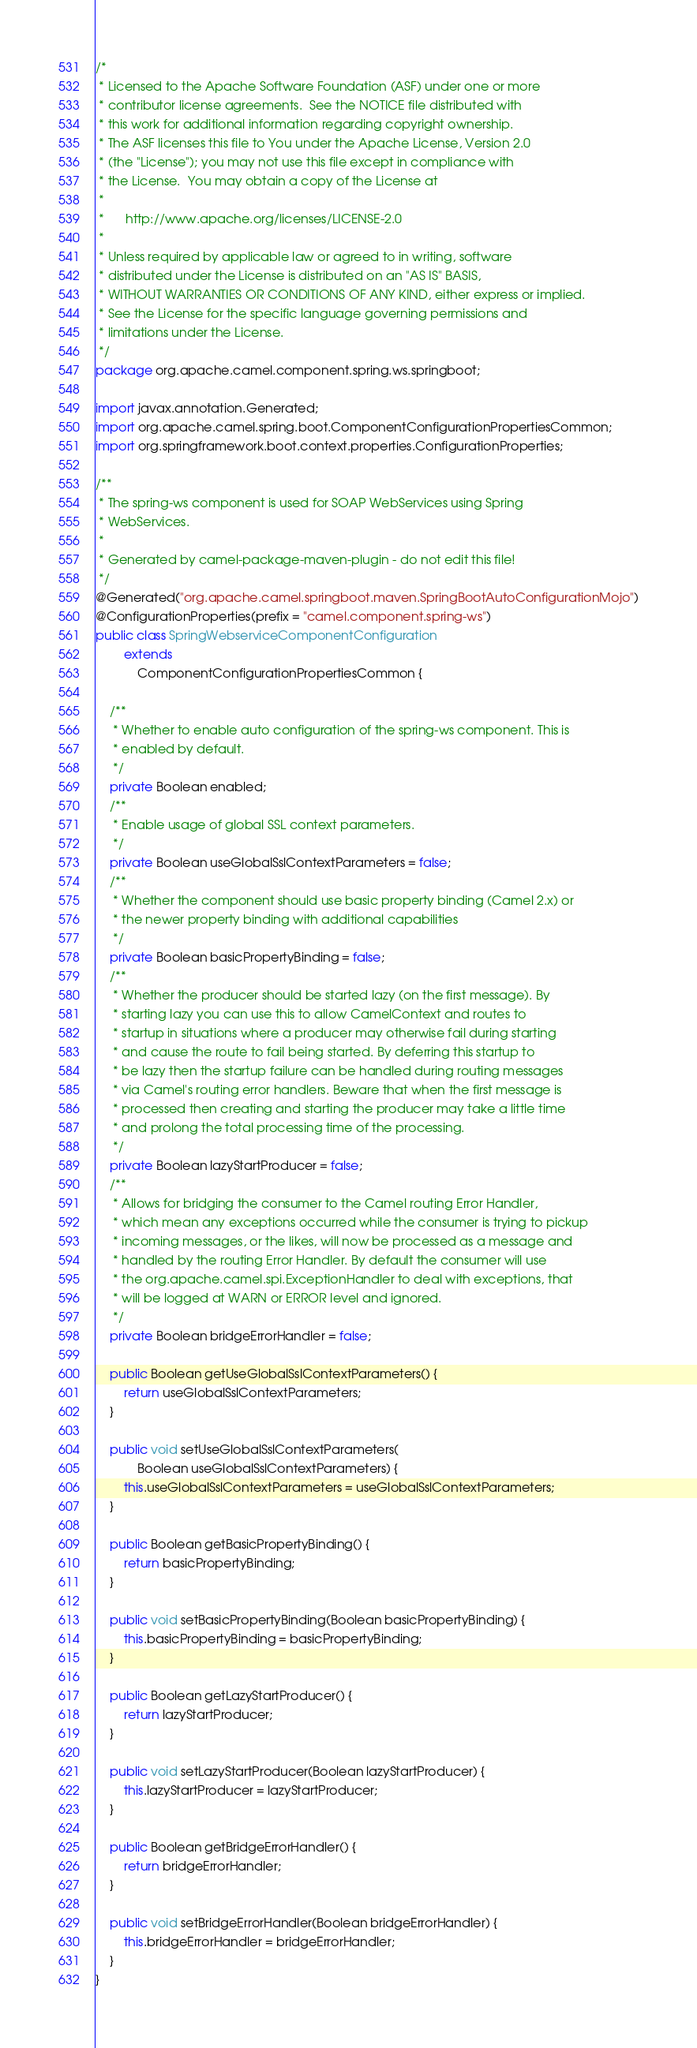Convert code to text. <code><loc_0><loc_0><loc_500><loc_500><_Java_>/*
 * Licensed to the Apache Software Foundation (ASF) under one or more
 * contributor license agreements.  See the NOTICE file distributed with
 * this work for additional information regarding copyright ownership.
 * The ASF licenses this file to You under the Apache License, Version 2.0
 * (the "License"); you may not use this file except in compliance with
 * the License.  You may obtain a copy of the License at
 *
 *      http://www.apache.org/licenses/LICENSE-2.0
 *
 * Unless required by applicable law or agreed to in writing, software
 * distributed under the License is distributed on an "AS IS" BASIS,
 * WITHOUT WARRANTIES OR CONDITIONS OF ANY KIND, either express or implied.
 * See the License for the specific language governing permissions and
 * limitations under the License.
 */
package org.apache.camel.component.spring.ws.springboot;

import javax.annotation.Generated;
import org.apache.camel.spring.boot.ComponentConfigurationPropertiesCommon;
import org.springframework.boot.context.properties.ConfigurationProperties;

/**
 * The spring-ws component is used for SOAP WebServices using Spring
 * WebServices.
 * 
 * Generated by camel-package-maven-plugin - do not edit this file!
 */
@Generated("org.apache.camel.springboot.maven.SpringBootAutoConfigurationMojo")
@ConfigurationProperties(prefix = "camel.component.spring-ws")
public class SpringWebserviceComponentConfiguration
        extends
            ComponentConfigurationPropertiesCommon {

    /**
     * Whether to enable auto configuration of the spring-ws component. This is
     * enabled by default.
     */
    private Boolean enabled;
    /**
     * Enable usage of global SSL context parameters.
     */
    private Boolean useGlobalSslContextParameters = false;
    /**
     * Whether the component should use basic property binding (Camel 2.x) or
     * the newer property binding with additional capabilities
     */
    private Boolean basicPropertyBinding = false;
    /**
     * Whether the producer should be started lazy (on the first message). By
     * starting lazy you can use this to allow CamelContext and routes to
     * startup in situations where a producer may otherwise fail during starting
     * and cause the route to fail being started. By deferring this startup to
     * be lazy then the startup failure can be handled during routing messages
     * via Camel's routing error handlers. Beware that when the first message is
     * processed then creating and starting the producer may take a little time
     * and prolong the total processing time of the processing.
     */
    private Boolean lazyStartProducer = false;
    /**
     * Allows for bridging the consumer to the Camel routing Error Handler,
     * which mean any exceptions occurred while the consumer is trying to pickup
     * incoming messages, or the likes, will now be processed as a message and
     * handled by the routing Error Handler. By default the consumer will use
     * the org.apache.camel.spi.ExceptionHandler to deal with exceptions, that
     * will be logged at WARN or ERROR level and ignored.
     */
    private Boolean bridgeErrorHandler = false;

    public Boolean getUseGlobalSslContextParameters() {
        return useGlobalSslContextParameters;
    }

    public void setUseGlobalSslContextParameters(
            Boolean useGlobalSslContextParameters) {
        this.useGlobalSslContextParameters = useGlobalSslContextParameters;
    }

    public Boolean getBasicPropertyBinding() {
        return basicPropertyBinding;
    }

    public void setBasicPropertyBinding(Boolean basicPropertyBinding) {
        this.basicPropertyBinding = basicPropertyBinding;
    }

    public Boolean getLazyStartProducer() {
        return lazyStartProducer;
    }

    public void setLazyStartProducer(Boolean lazyStartProducer) {
        this.lazyStartProducer = lazyStartProducer;
    }

    public Boolean getBridgeErrorHandler() {
        return bridgeErrorHandler;
    }

    public void setBridgeErrorHandler(Boolean bridgeErrorHandler) {
        this.bridgeErrorHandler = bridgeErrorHandler;
    }
}</code> 